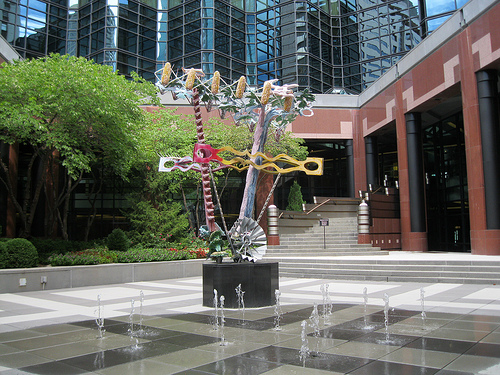<image>
Is the statue in the water? Yes. The statue is contained within or inside the water, showing a containment relationship. Where is the statue in relation to the water feature? Is it on the water feature? Yes. Looking at the image, I can see the statue is positioned on top of the water feature, with the water feature providing support. 